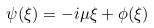<formula> <loc_0><loc_0><loc_500><loc_500>\psi ( \xi ) = - i \mu \xi + \phi ( \xi )</formula> 